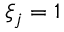<formula> <loc_0><loc_0><loc_500><loc_500>\xi _ { j } = 1</formula> 